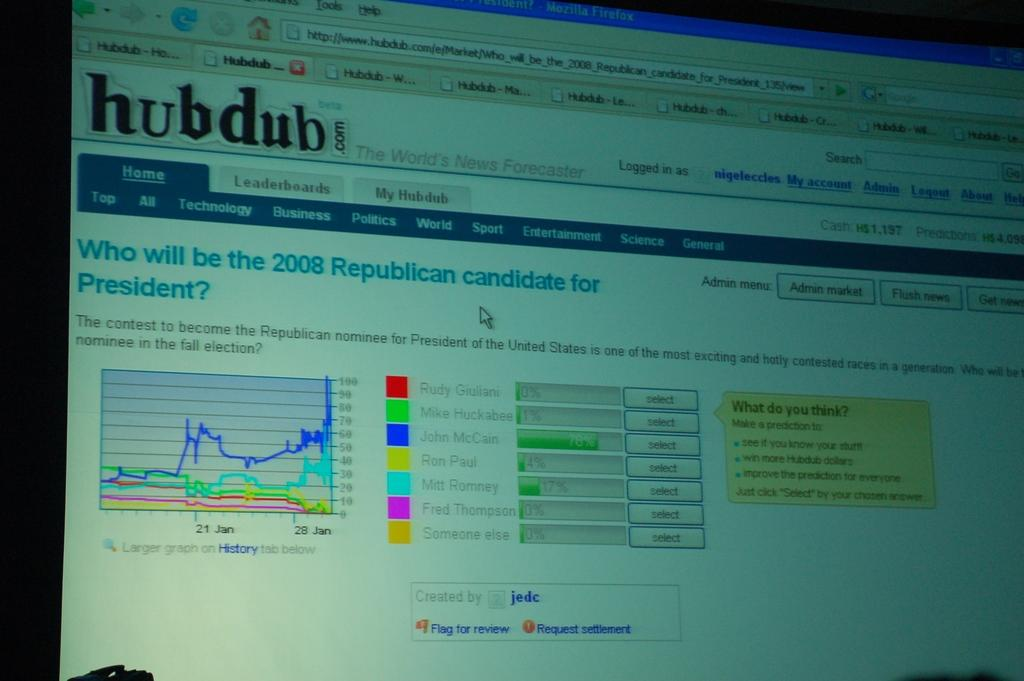<image>
Describe the image concisely. a computer monitor screen open to a Hub Dub page 